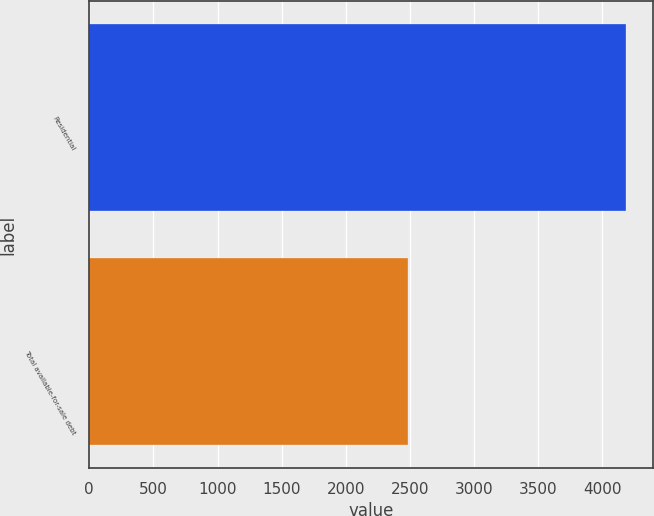<chart> <loc_0><loc_0><loc_500><loc_500><bar_chart><fcel>Residential<fcel>Total available-for-sale debt<nl><fcel>4187<fcel>2488<nl></chart> 